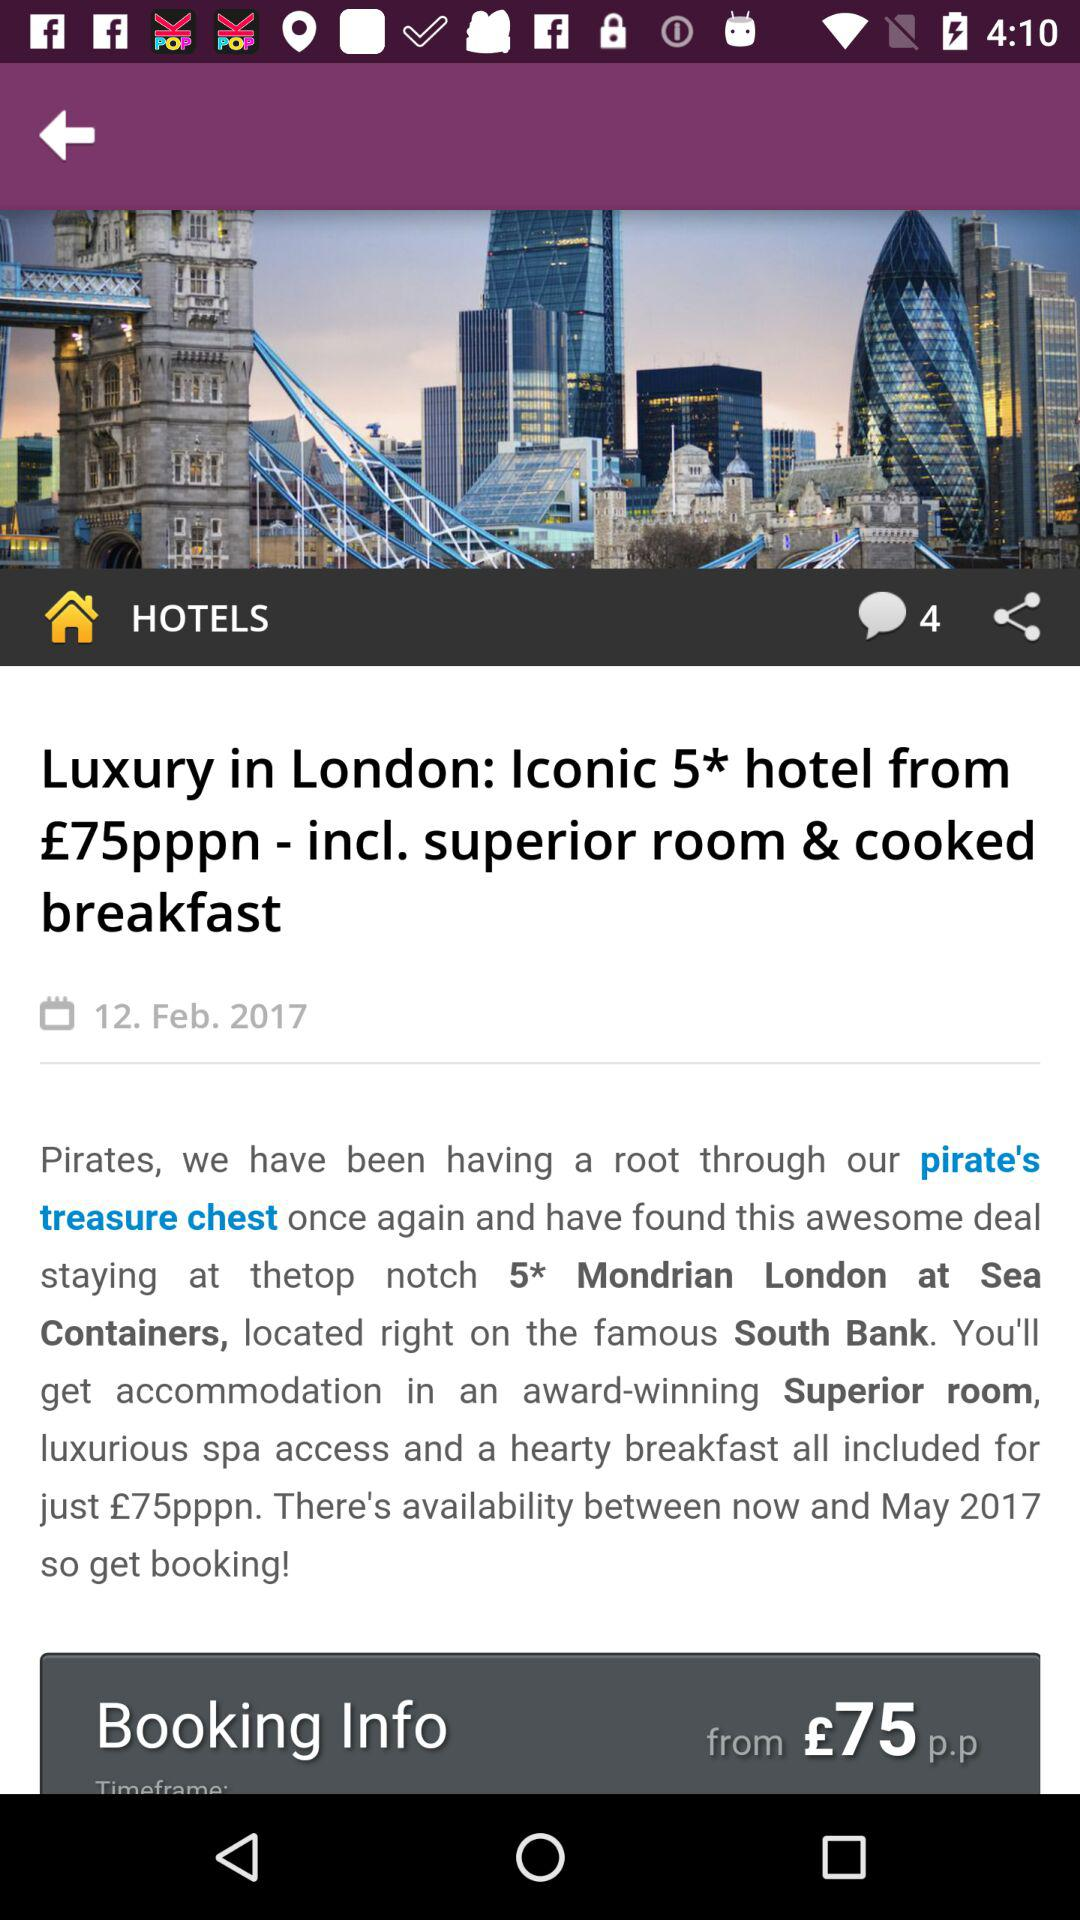How many comments are there in total? There are 4 comments in total. 